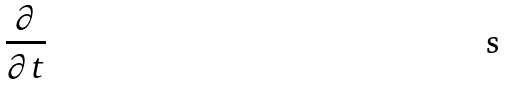Convert formula to latex. <formula><loc_0><loc_0><loc_500><loc_500>\frac { \partial } { \partial t }</formula> 